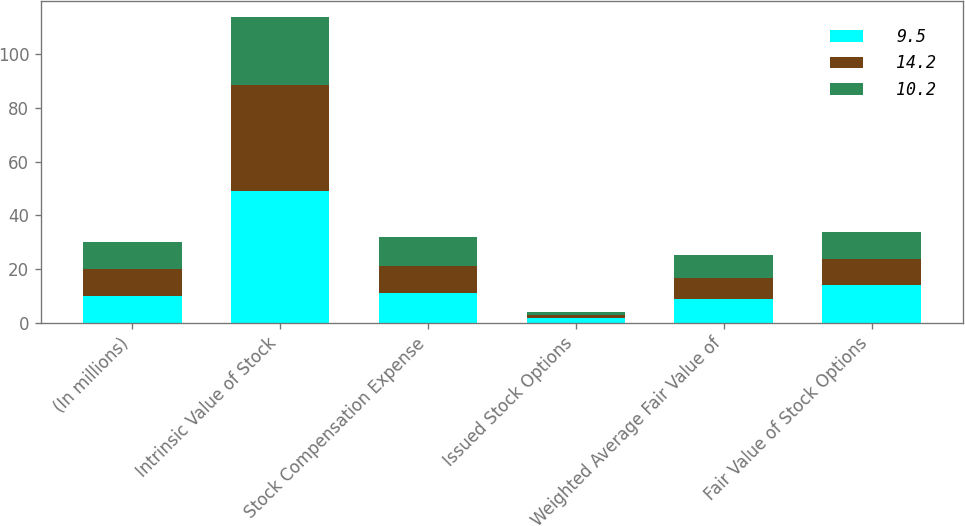<chart> <loc_0><loc_0><loc_500><loc_500><stacked_bar_chart><ecel><fcel>(In millions)<fcel>Intrinsic Value of Stock<fcel>Stock Compensation Expense<fcel>Issued Stock Options<fcel>Weighted Average Fair Value of<fcel>Fair Value of Stock Options<nl><fcel>9.5<fcel>10<fcel>48.9<fcel>11<fcel>1.6<fcel>8.92<fcel>14.2<nl><fcel>14.2<fcel>10<fcel>39.6<fcel>10<fcel>1.2<fcel>7.87<fcel>9.5<nl><fcel>10.2<fcel>10<fcel>25.5<fcel>10.9<fcel>1.2<fcel>8.36<fcel>10.2<nl></chart> 